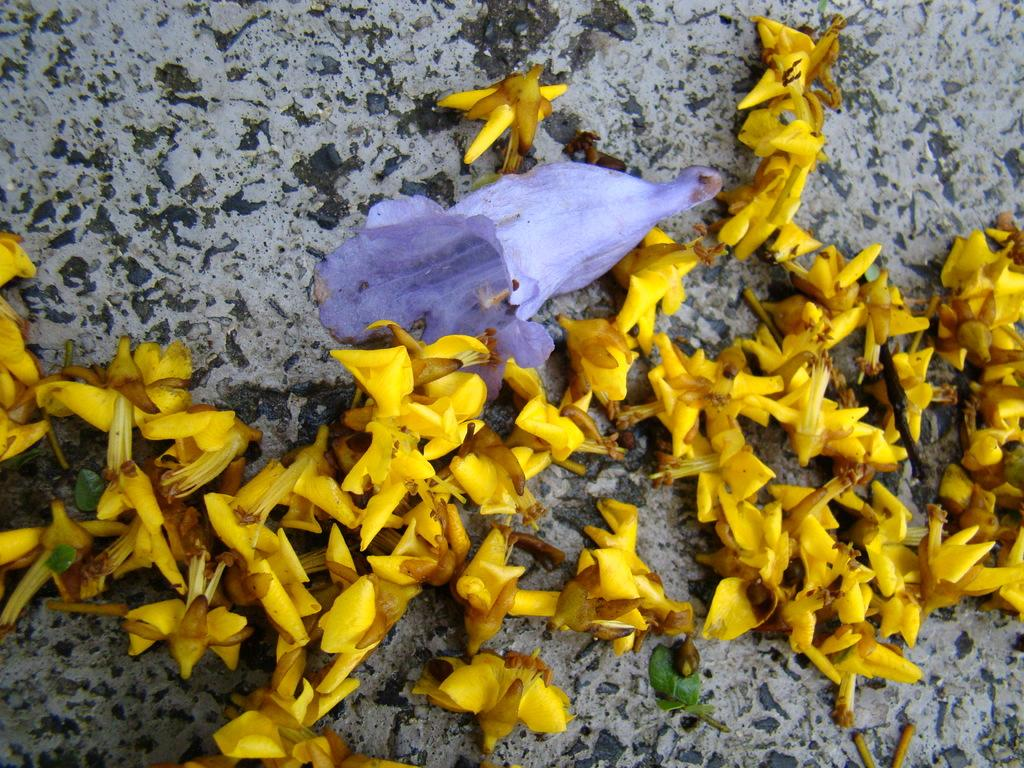What colors are the flowers in the image? The flowers in the image are yellow and purple. What is the color of the surface in the image? The surface in the image is black and ash color. What type of suit is hanging on the string in the image? There is no suit or string present in the image; it only features flowers and a black and ash surface. 